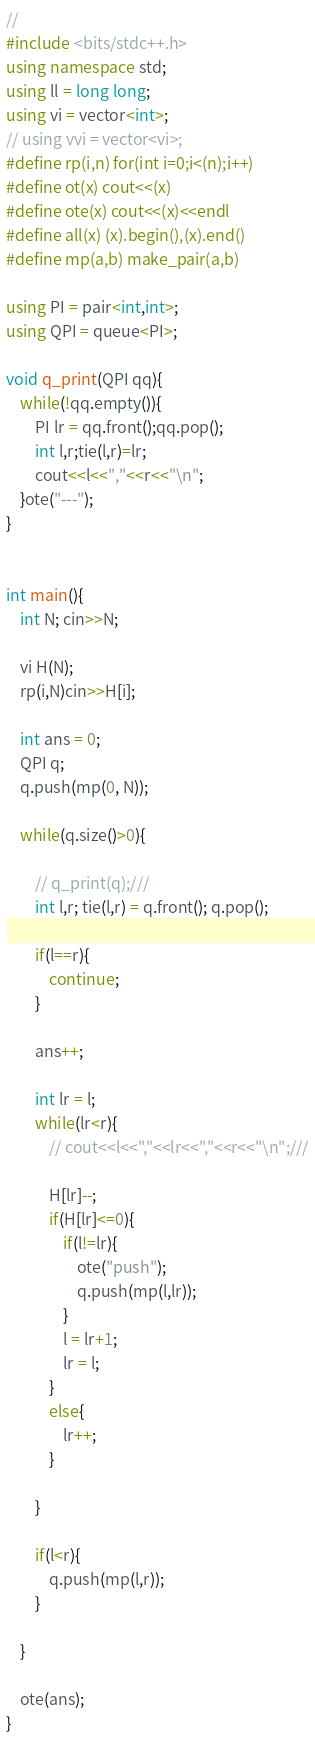Convert code to text. <code><loc_0><loc_0><loc_500><loc_500><_C++_>//
#include <bits/stdc++.h>
using namespace std;
using ll = long long;
using vi = vector<int>;
// using vvi = vector<vi>;
#define rp(i,n) for(int i=0;i<(n);i++)
#define ot(x) cout<<(x)
#define ote(x) cout<<(x)<<endl
#define all(x) (x).begin(),(x).end()
#define mp(a,b) make_pair(a,b)

using PI = pair<int,int>;
using QPI = queue<PI>;

void q_print(QPI qq){
	while(!qq.empty()){
		PI lr = qq.front();qq.pop();
		int l,r;tie(l,r)=lr;
		cout<<l<<","<<r<<"\n";
	}ote("---");
}


int main(){
	int N; cin>>N;

	vi H(N);
	rp(i,N)cin>>H[i];

	int ans = 0;
	QPI q;
	q.push(mp(0, N));

	while(q.size()>0){

		// q_print(q);///
		int l,r; tie(l,r) = q.front(); q.pop();

		if(l==r){
			continue;
		}

		ans++;

		int lr = l;
		while(lr<r){
			// cout<<l<<","<<lr<<","<<r<<"\n";///

			H[lr]--;
			if(H[lr]<=0){
				if(l!=lr){
					ote("push");
					q.push(mp(l,lr));
				}
				l = lr+1;
				lr = l;
			}
			else{
				lr++;
			}

		}

		if(l<r){
			q.push(mp(l,r));
		}

	}

	ote(ans);
}
</code> 